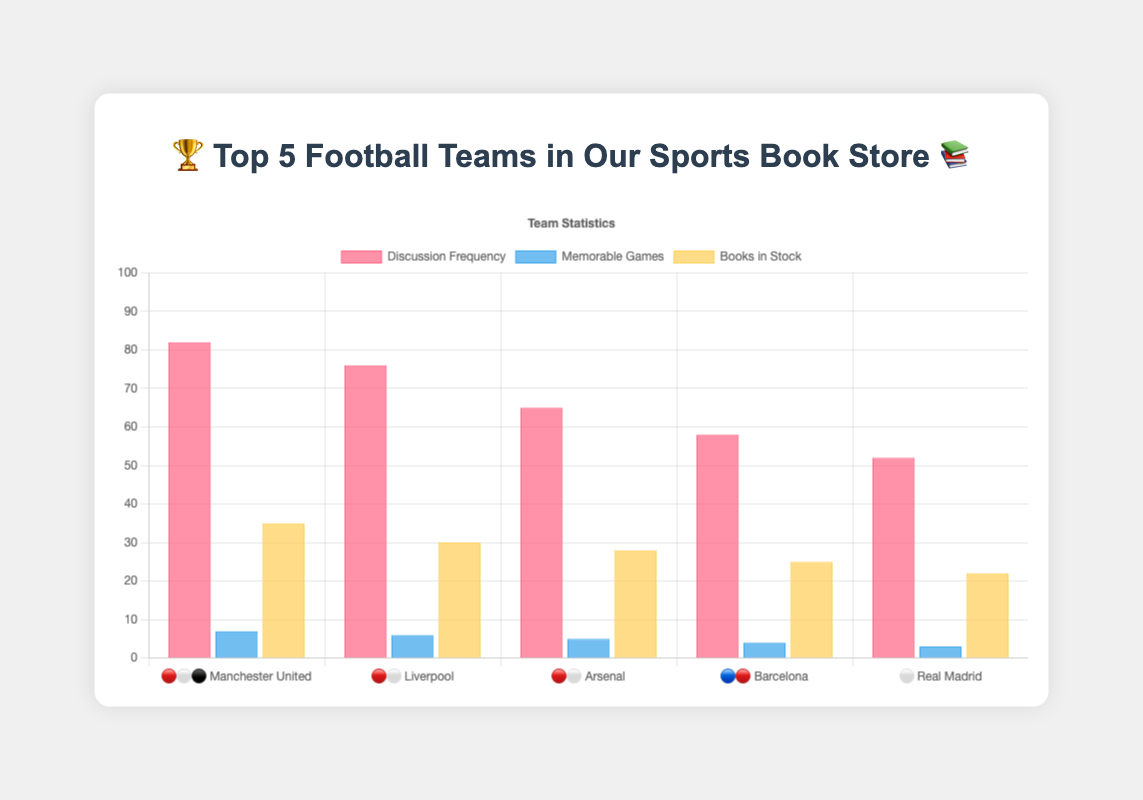What's the team with the highest discussion frequency? By looking at the heights of the bars representing 'Discussion Frequency' in the red-pink color, the bar for Manchester United is the tallest with a value of 82.
Answer: Manchester United How many memorable games did Arsenal have? Find the blue bar for Arsenal among other teams and read its height. The value is 5, indicating 5 memorable games.
Answer: 5 Which team has the fewest books in stock? Identify the yellow bars representing 'Books in Stock' for each team. The Real Madrid bar is the shortest with a value of 22.
Answer: Real Madrid What is the average discussion frequency of Liverpool and Barcelona? Add the discussion frequencies of Liverpool (76) and Barcelona (58), then divide by 2. So, (76 + 58) / 2 = 67.
Answer: 67 What's the total number of memorable games for all teams combined? Sum up the values of the blue bars for all teams (7+6+5+4+3). Therefore, 7 + 6 + 5 + 4 + 3 = 25.
Answer: 25 What's the difference in books in stock between Manchester United and Arsenal? Subtract the number of books in stock for Arsenal (28) from Manchester United (35). So, 35 - 28 = 7.
Answer: 7 Which team has a higher memorable game count, Liverpool or Barcelona? Compare the heights of the blue bars for Liverpool and Barcelona. Liverpool has 6 memorable games and Barcelona has 4.
Answer: Liverpool What's the combined discussion frequency for all teams? Add the discussion frequencies for all teams together (82+76+65+58+52). Therefore, 82 + 76 + 65 + 58 + 52 = 333.
Answer: 333 Do Real Madrid and Barcelona have the same number of memorable games? By comparing the heights of the blue bars for Real Madrid (3) and Barcelona (4), we see they are not the same.
Answer: No Which team has the most consistent number in all three categories (discussion frequency, memorable games, books in stock)? Look for the team with the least variation among the three bar heights. All teams vary, but Liverpool seems to have relatively even numbers (76, 6, 30).
Answer: Liverpool 